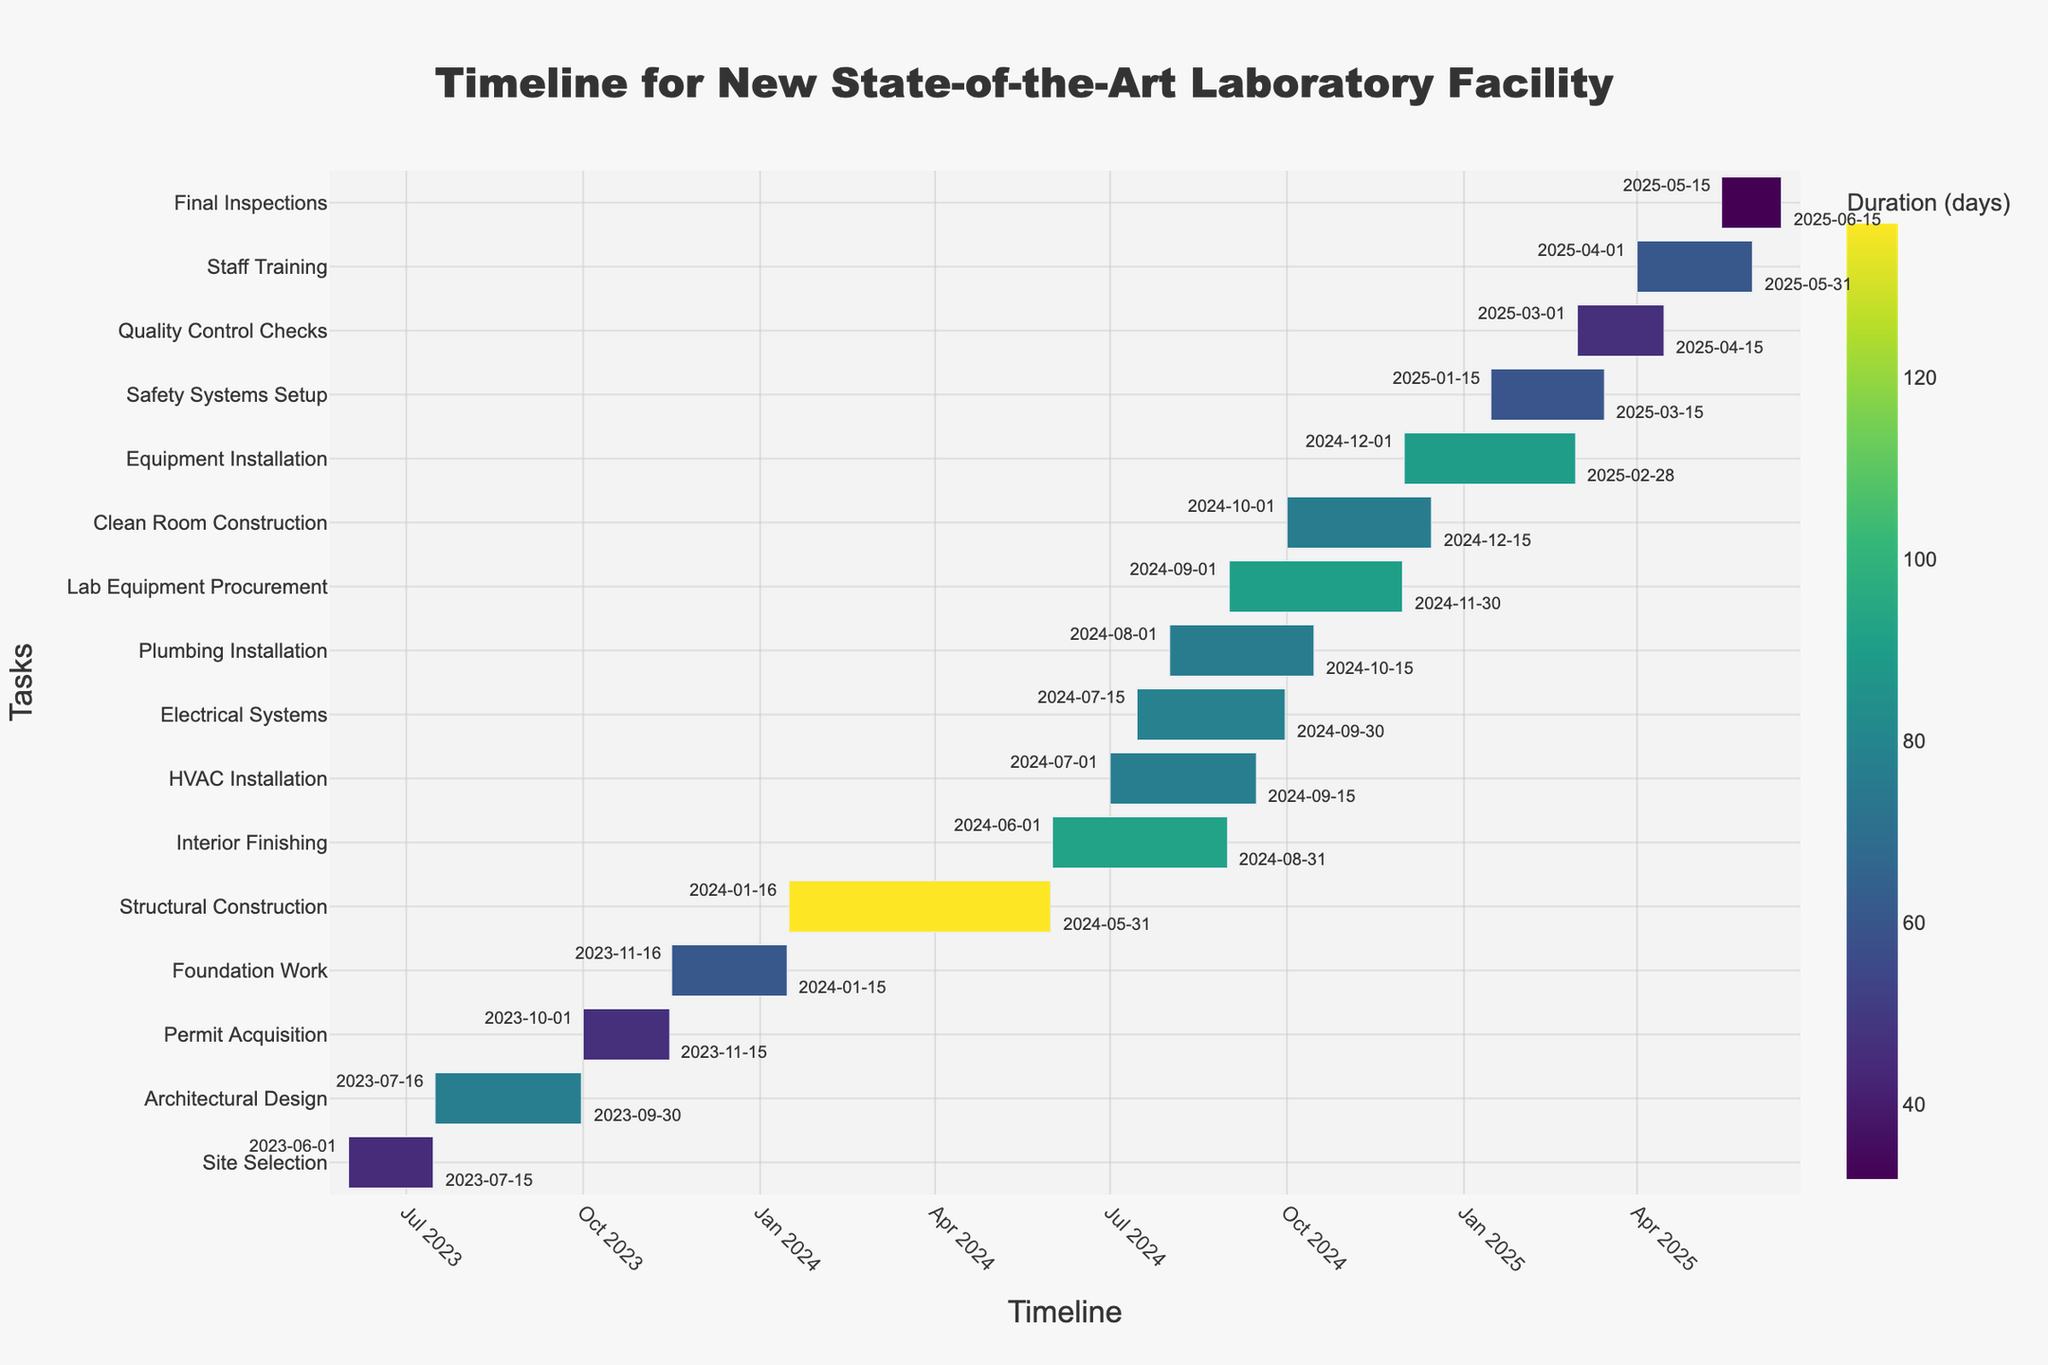what is the title of the figure? The title of the figure is displayed prominently at the top. It states "Timeline for New State-of-the-Art Laboratory Facility".
Answer: Timeline for New State-of-the-Art Laboratory Facility What is the duration of the foundation work? The "Foundation Work" task starts on 2023-11-16 and ends on 2024-01-15. The duration of this task is provided in the data as 61 days.
Answer: 61 days Which task has the longest duration and how many days does it span? By looking at the color intensity and the duration labels, "Structural Construction" has the longest duration, which is 137 days.
Answer: Structural Construction, 137 days Which task immediately follows the "Permit Acquisition"? The "Foundation Work" task starts immediately after the "Permit Acquisition" task ends. Permit Acquisition ends on 2023-11-15, and Foundation Work starts on 2023-11-16.
Answer: Foundation Work How many days are there between the start of "Architectural Design" and the end of "Permit Acquisition"? "Architectural Design" starts on 2023-07-16, and "Permit Acquisition" ends on 2023-11-15. The number of days between these dates is calculated by subtracting the first date from the second.
Answer: 122 days What overlap can be observed between "HVAC Installation" and "Electrical Systems"? "HVAC Installation" starts on 2024-07-01 and ends on 2024-09-15, while "Electrical Systems" starts on 2024-07-15 and ends on 2024-09-30. Both tasks overlap from 2024-07-15 to 2024-09-15.
Answer: 62 days When do "Quality Control Checks" begin and when is their scheduled completion? "Quality Control Checks" begin on 2025-03-01 and are scheduled to be completed by 2025-04-15.
Answer: 2025-03-01 to 2025-04-15 Which tasks are scheduled to be performed concurrently with "Clean Room Construction"? "Clean Room Construction" takes place from 2024-10-01 to 2024-12-15. The other tasks with overlapping timelines include "Lab Equipment Procurement" (2024-09-01 to 2024-11-30) and "Equipment Installation" (2024-12-01 to 2025-02-28).
Answer: Lab Equipment Procurement, Equipment Installation What is the total project duration? The project starts with "Site Selection" on 2023-06-01 and ends with "Final Inspections" on 2025-06-15. The total duration is the number of days between these dates.
Answer: 745 days How many tasks start in July 2024? According to the figure, the tasks that start in July 2024 are "HVAC Installation" (2024-07-01) and "Electrical Systems" (2024-07-15).
Answer: 2 tasks 